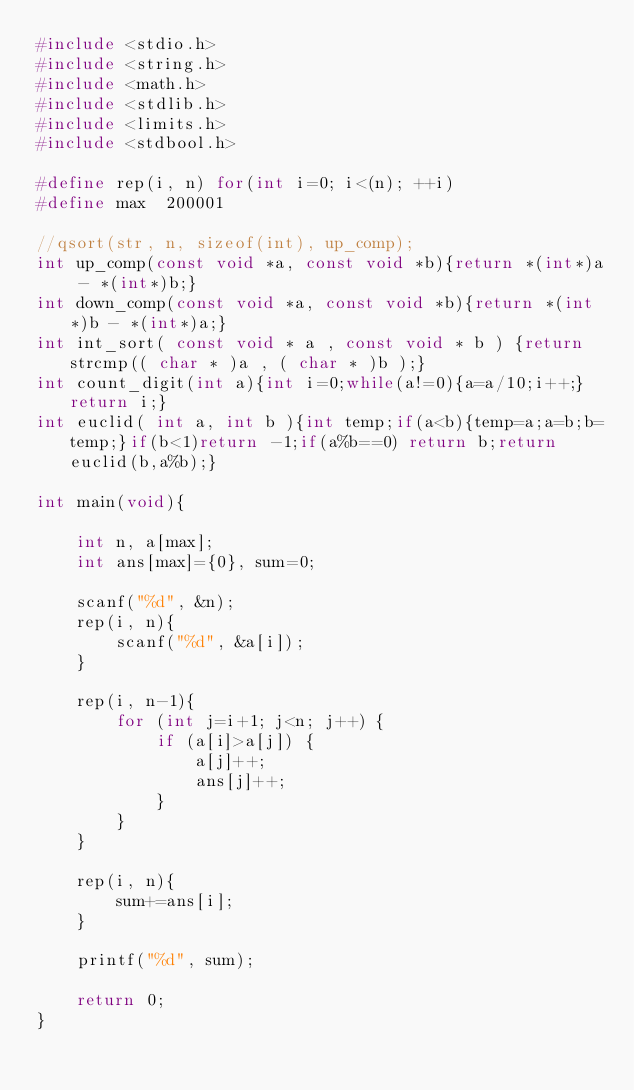<code> <loc_0><loc_0><loc_500><loc_500><_C_>#include <stdio.h>
#include <string.h>
#include <math.h>
#include <stdlib.h>
#include <limits.h>
#include <stdbool.h>

#define rep(i, n) for(int i=0; i<(n); ++i)
#define max  200001

//qsort(str, n, sizeof(int), up_comp);
int up_comp(const void *a, const void *b){return *(int*)a - *(int*)b;}
int down_comp(const void *a, const void *b){return *(int*)b - *(int*)a;}
int int_sort( const void * a , const void * b ) {return strcmp(( char * )a , ( char * )b );}
int count_digit(int a){int i=0;while(a!=0){a=a/10;i++;}return i;}
int euclid( int a, int b ){int temp;if(a<b){temp=a;a=b;b=temp;}if(b<1)return -1;if(a%b==0) return b;return euclid(b,a%b);}

int main(void){
    
    int n, a[max];
    int ans[max]={0}, sum=0;
    
    scanf("%d", &n);
    rep(i, n){
        scanf("%d", &a[i]);
    }
    
    rep(i, n-1){
        for (int j=i+1; j<n; j++) {
            if (a[i]>a[j]) {
                a[j]++;
                ans[j]++;
            }
        }
    }
    
    rep(i, n){
        sum+=ans[i];
    }
    
    printf("%d", sum);

    return 0;
}
</code> 